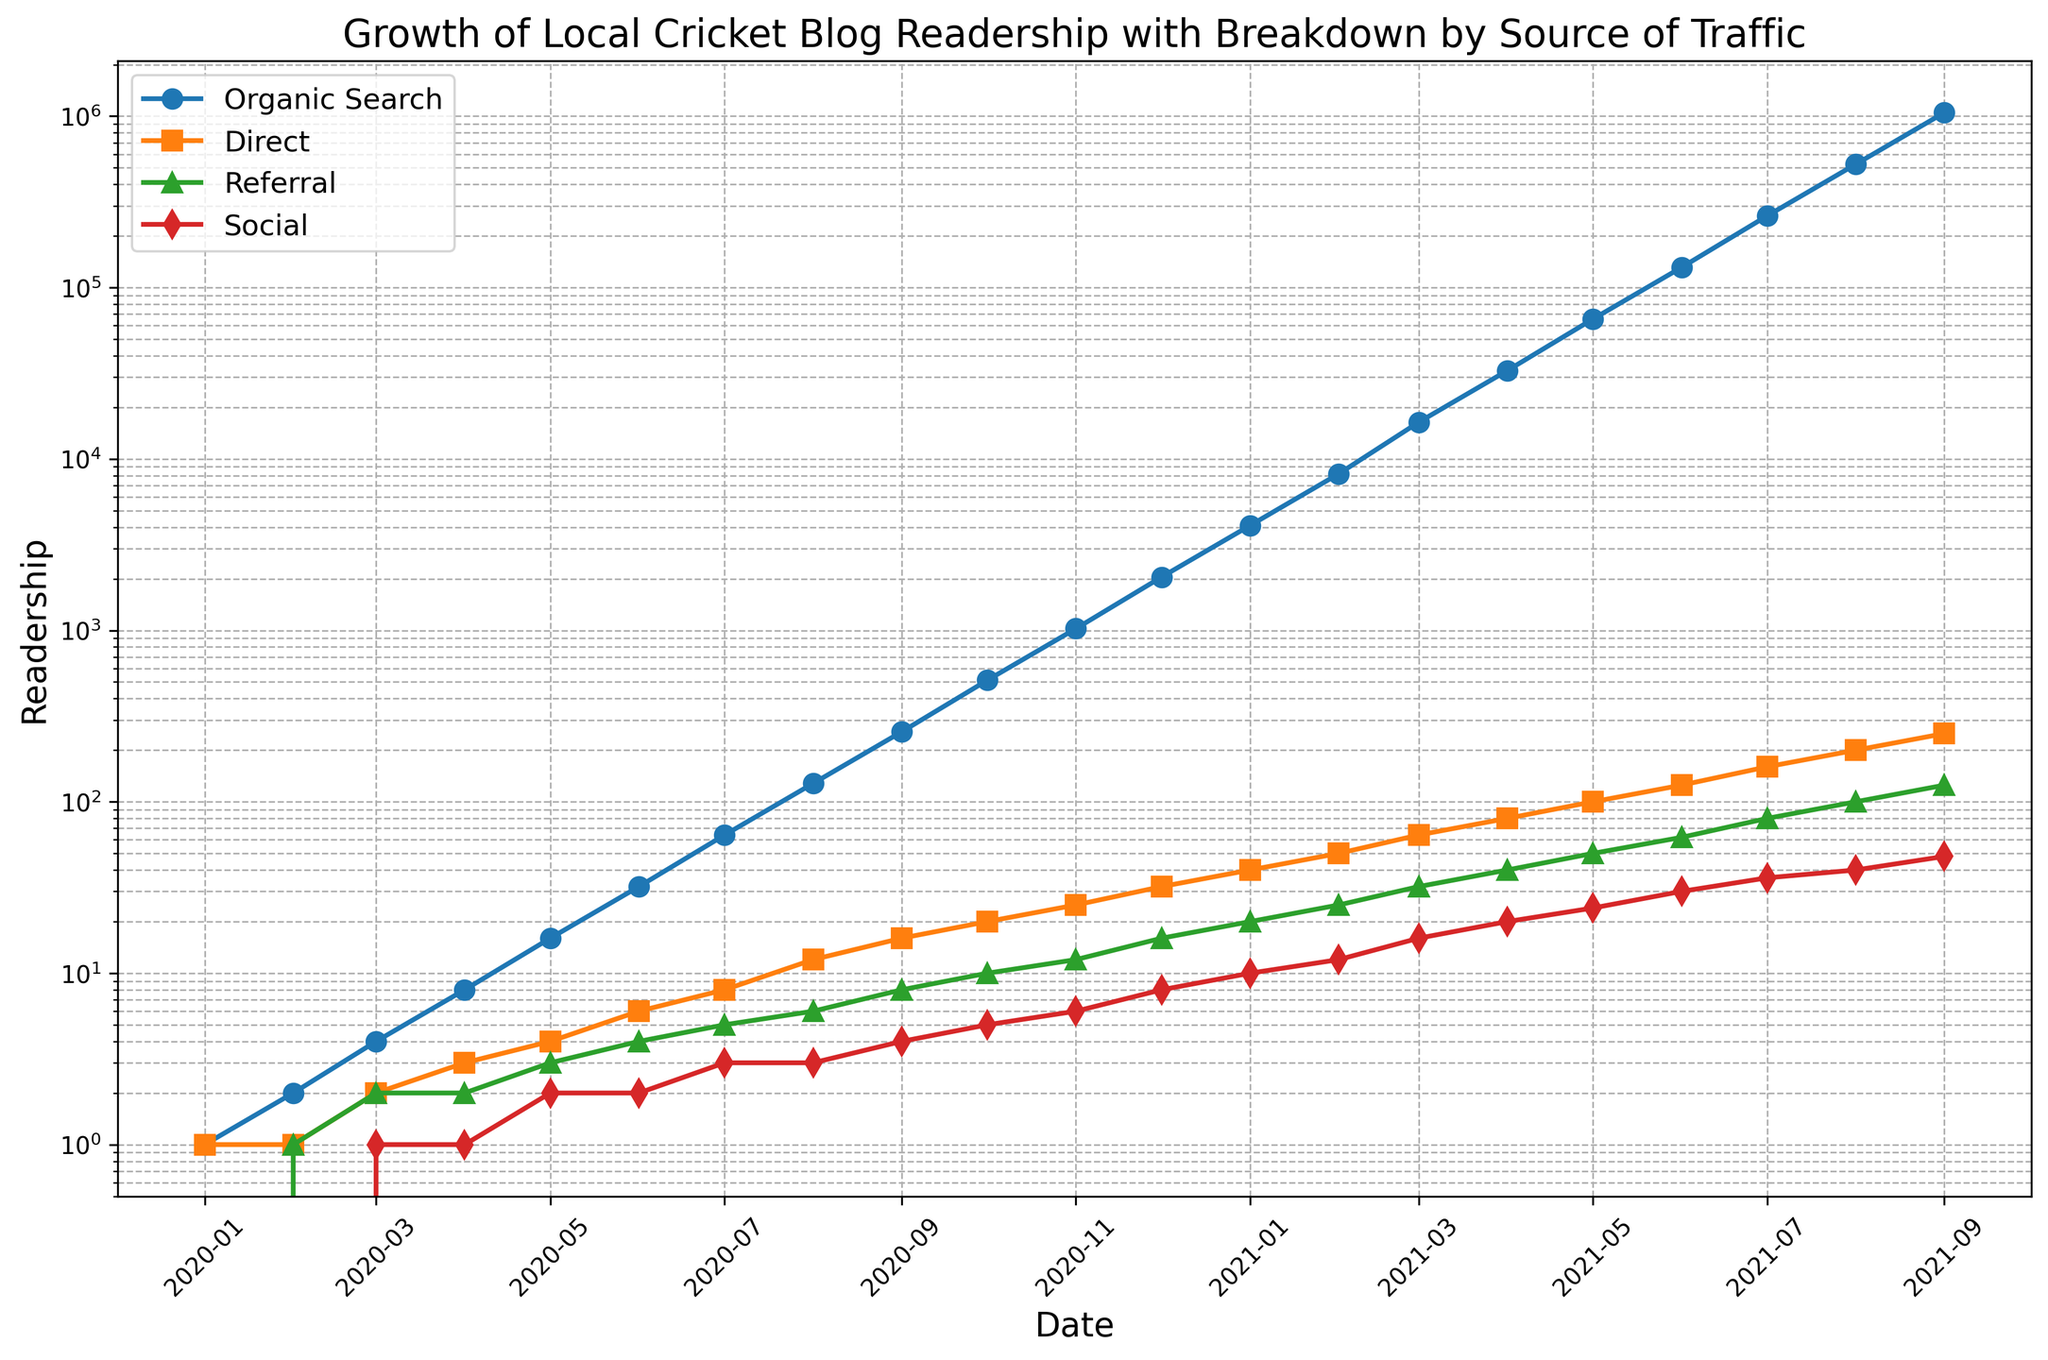What is the main trend observed in organic search traffic over the period? The plot shows that the organic search traffic has an exponential growth trend over time. This can be seen from the continuous sharp increase in the number of readers from January 2020 to September 2021, with no major drops or plateaus.
Answer: Exponential growth How does the growth of direct traffic compare to referral traffic? Throughout the plotted period, direct traffic grows at a slower rate compared to organic search but shows more growth than referral traffic. Direct starts higher and has a sharper upward slope compared to referral, indicating a more significant increase over time.
Answer: Direct grows faster than referral At what point does social media traffic begin to show notable increases? Social media traffic begins to show a notable increase starting around May 2020. Before that, the number is relatively flat, but after May, there is a visible upward trend.
Answer: May 2020 By what factor did organic search traffic increase from January 2020 to September 2021? To find the factor, we compare the value in September 2021 (1048576) to the value in January 2020 (1). The factor is 1048576 / 1 = 1048576.
Answer: 1048576 Which source of traffic had the least growth over the entire period? Given the plot, referral traffic shows the least growth compared to organic search, direct, and social media. It starts low and increases but remains the smallest increase in comparison.
Answer: Referral traffic In which month did organic search traffic first surpass 100,000 readers? By inspecting the plot, organic search traffic first surpasses 100,000 readers in May 2021.
Answer: May 2021 What was the combined readership of direct and social media traffic in January 2021? The readership for direct traffic in January 2021 is 40 and for social media, it is 10. Adding these together: 40 + 10 = 50.
Answer: 50 Compare the growth rates of direct and social traffic from January 2021 to September 2021. In January 2021, direct traffic is at 40 readers and reaches 250 by September 2021. Social media traffic is at 10 readers in January and reaches 48 by September 2021. Direct traffic grows by a factor of 250/40 = 6.25, while social media traffic grows by a factor of 48/10 = 4.8. Therefore, direct traffic had a higher growth rate.
Answer: Direct traffic Which traffic source shows the most consistent logarithmic growth? Organic search traffic shows the most consistent logarithmic growth as evidenced by its straight line on the logarithmic scale over the plotted period.
Answer: Organic search 